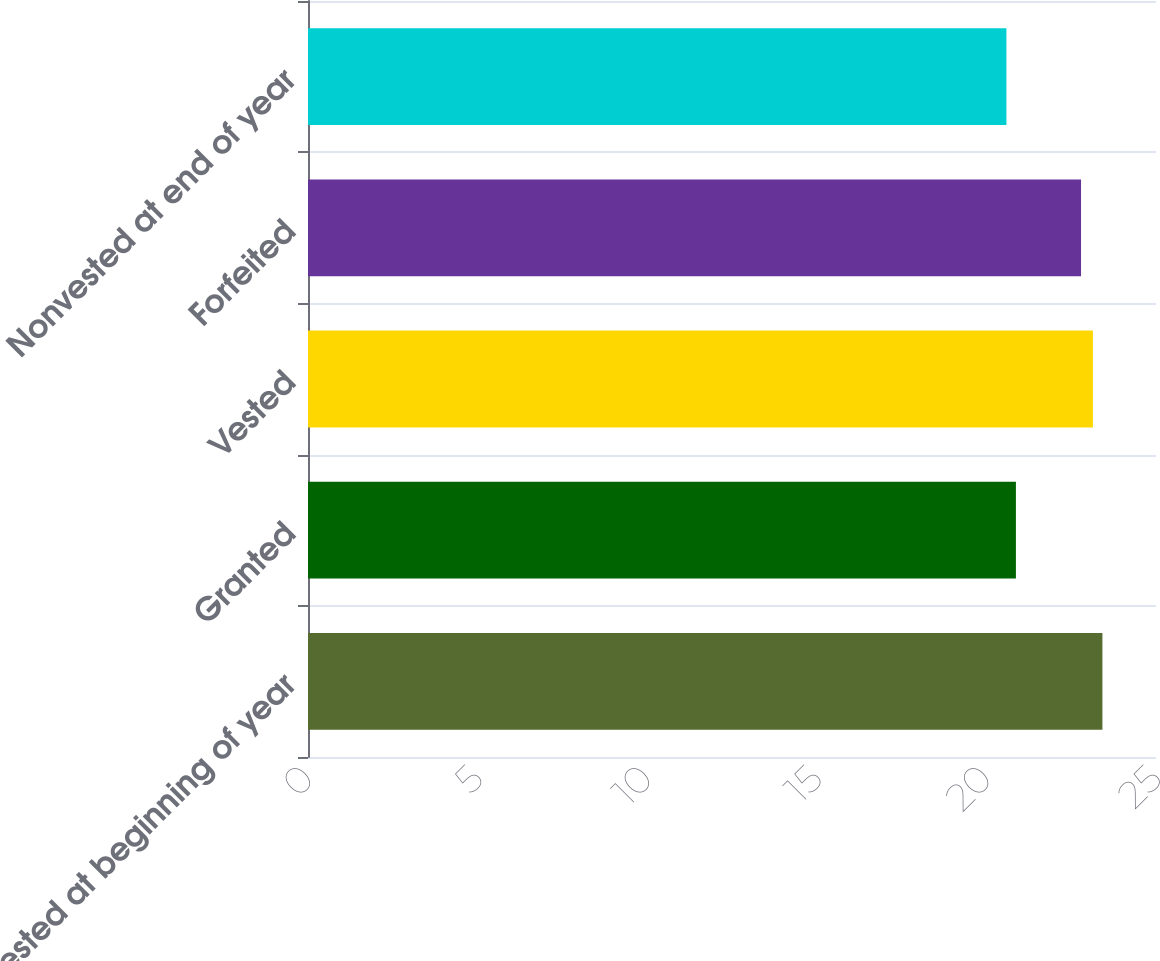<chart> <loc_0><loc_0><loc_500><loc_500><bar_chart><fcel>Nonvested at beginning of year<fcel>Granted<fcel>Vested<fcel>Forfeited<fcel>Nonvested at end of year<nl><fcel>23.42<fcel>20.87<fcel>23.14<fcel>22.79<fcel>20.59<nl></chart> 